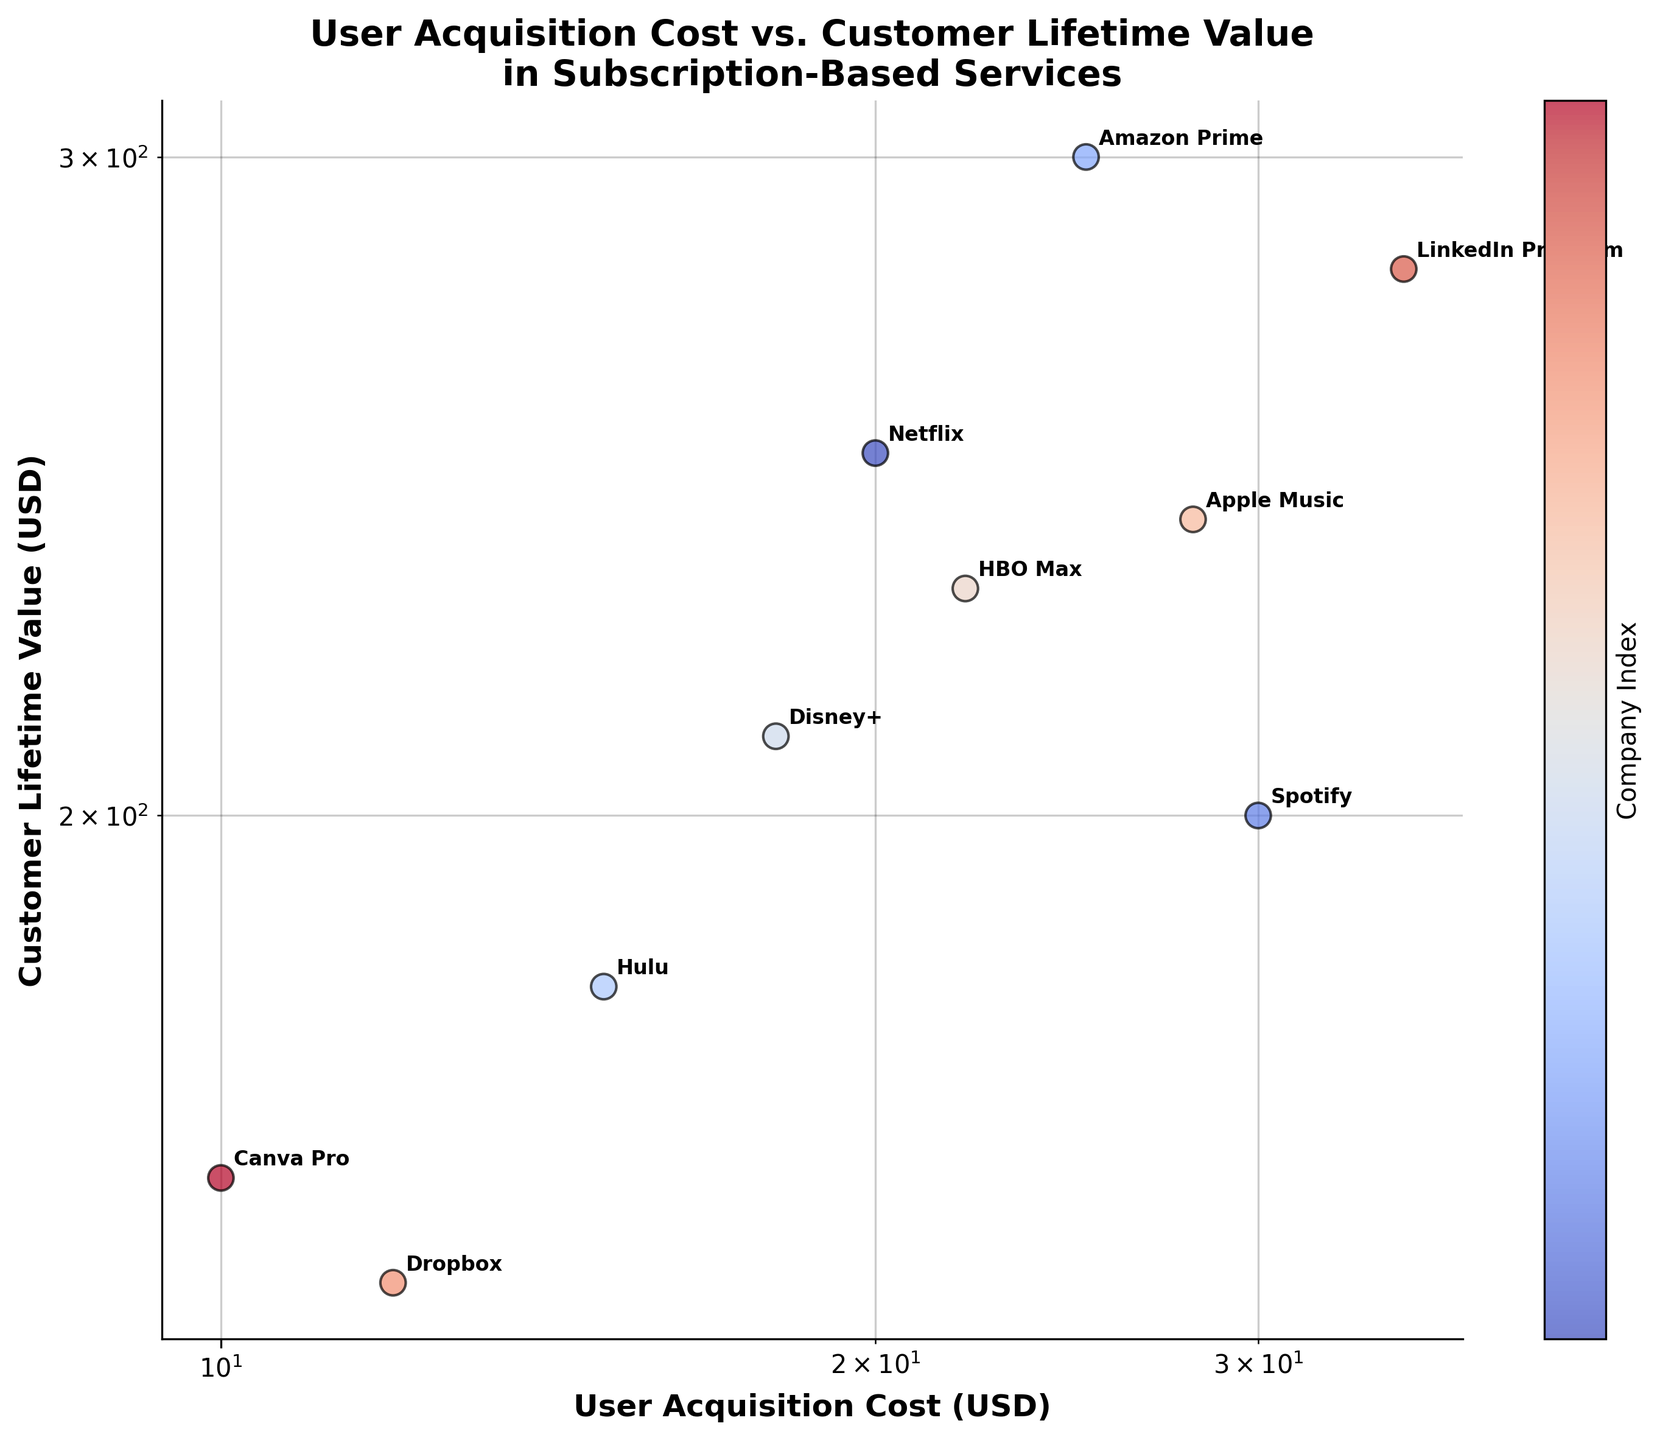What is the title of the plot? The title of the plot is presented at the top center. It reads "User Acquisition Cost vs. Customer Lifetime Value in Subscription-Based Services."
Answer: User Acquisition Cost vs. Customer Lifetime Value in Subscription-Based Services Which company has the highest Customer Lifetime Value? By examining the y-axis (Customer Lifetime Value) and the data points, it is clear that Amazon Prime has the highest value, as its point is located the highest on the y-axis.
Answer: Amazon Prime What is the range of the User Acquisition Cost in the plot? The x-axis (User Acquisition Cost) ranges from approximately 10 to 35 USD. The company with the lowest cost is Canva Pro at 10 USD, and the highest is LinkedIn Premium at 35 USD.
Answer: 10 to 35 USD How many companies have a Customer Lifetime Value greater than 200 USD? By looking at the y-axis and counting the data points above 200 USD, it can be observed that there are 5 companies: Netflix, Amazon Prime, HBO Max, Apple Music, and LinkedIn Premium.
Answer: 5 Which company has the closest balance between User Acquisition Cost and Customer Lifetime Value? The closest balance can be interpreted by finding the point closest to a 1:1 ratio line (slope of 1 through the origin) in a log-log scale. It seems like Hulu, with a cost of 15 USD and a value of 180 USD, is closest to this balance.
Answer: Hulu How does Netflix's User Acquisition Cost compare to Disney+? Netflix's User Acquisition Cost is 20 USD while Disney+'s is 18 USD. By comparing these two values on the x-axis, it can be concluded that Netflix's cost is slightly higher than Disney+'s.
Answer: Higher What is the average Customer Lifetime Value of all companies presented? First, sum up the Customer Lifetime Values: 250 + 200 + 300 + 180 + 210 + 230 + 240 + 150 + 280 + 160 = 2200. Then, divide this sum by the number of companies: 2200 / 10 = 220.
Answer: 220 Which company has the lowest User Acquisition Cost and how does its Customer Lifetime Value compare to Dropbox? Canva Pro has the lowest User Acquisition Cost at 10 USD. Comparing its Customer Lifetime Value of 160 USD to Dropbox's 150 USD, Canva Pro has a slightly higher value.
Answer: Canva Pro, higher Are there any companies that have both a lower User Acquisition Cost and a higher Customer Lifetime Value than Spotify? Comparing each company to Spotify (30 USD cost, 200 USD value), Dropbox (12 USD cost, 150 USD value) and Canva Pro (10 USD cost, 160 USD value) both have lower costs but none have a higher value.
Answer: No What trend can you observe between User Acquisition Cost and Customer Lifetime Value in this log-log scale plot? Generally, there is a positive correlation between the User Acquisition Cost and Customer Lifetime Value, as companies with higher acquisition costs tend to have higher lifetime values. This trend is visible by the upward slope from left to right on the plot.
Answer: Positive correlation 